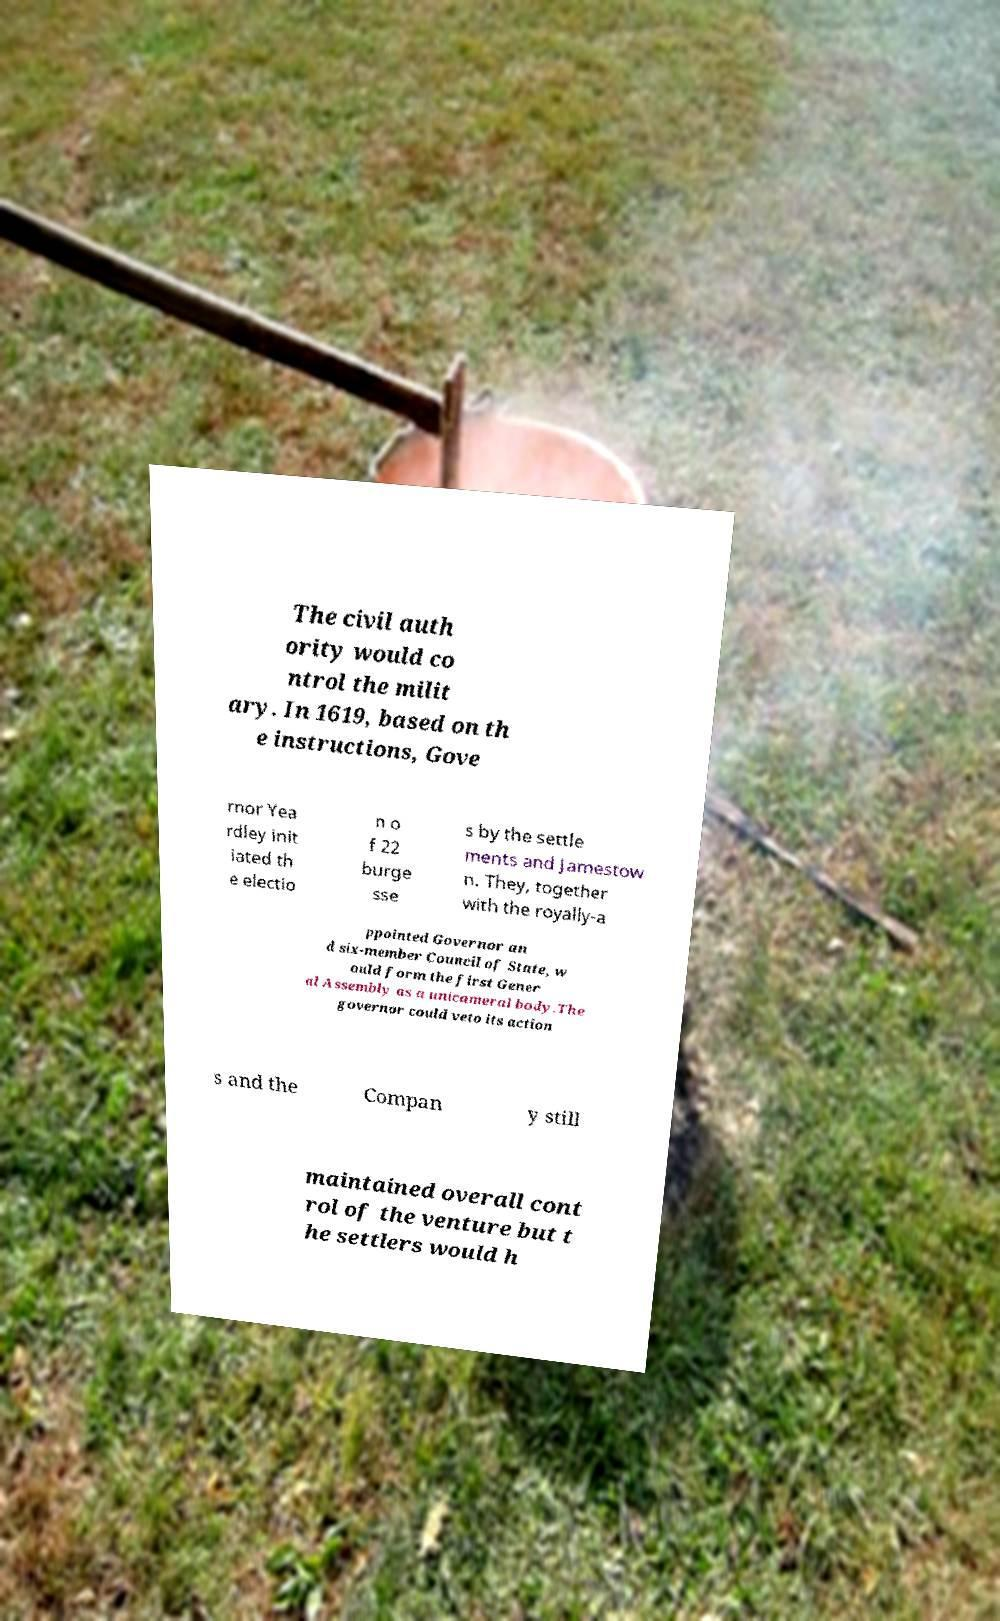Can you read and provide the text displayed in the image?This photo seems to have some interesting text. Can you extract and type it out for me? The civil auth ority would co ntrol the milit ary. In 1619, based on th e instructions, Gove rnor Yea rdley init iated th e electio n o f 22 burge sse s by the settle ments and Jamestow n. They, together with the royally-a ppointed Governor an d six-member Council of State, w ould form the first Gener al Assembly as a unicameral body.The governor could veto its action s and the Compan y still maintained overall cont rol of the venture but t he settlers would h 